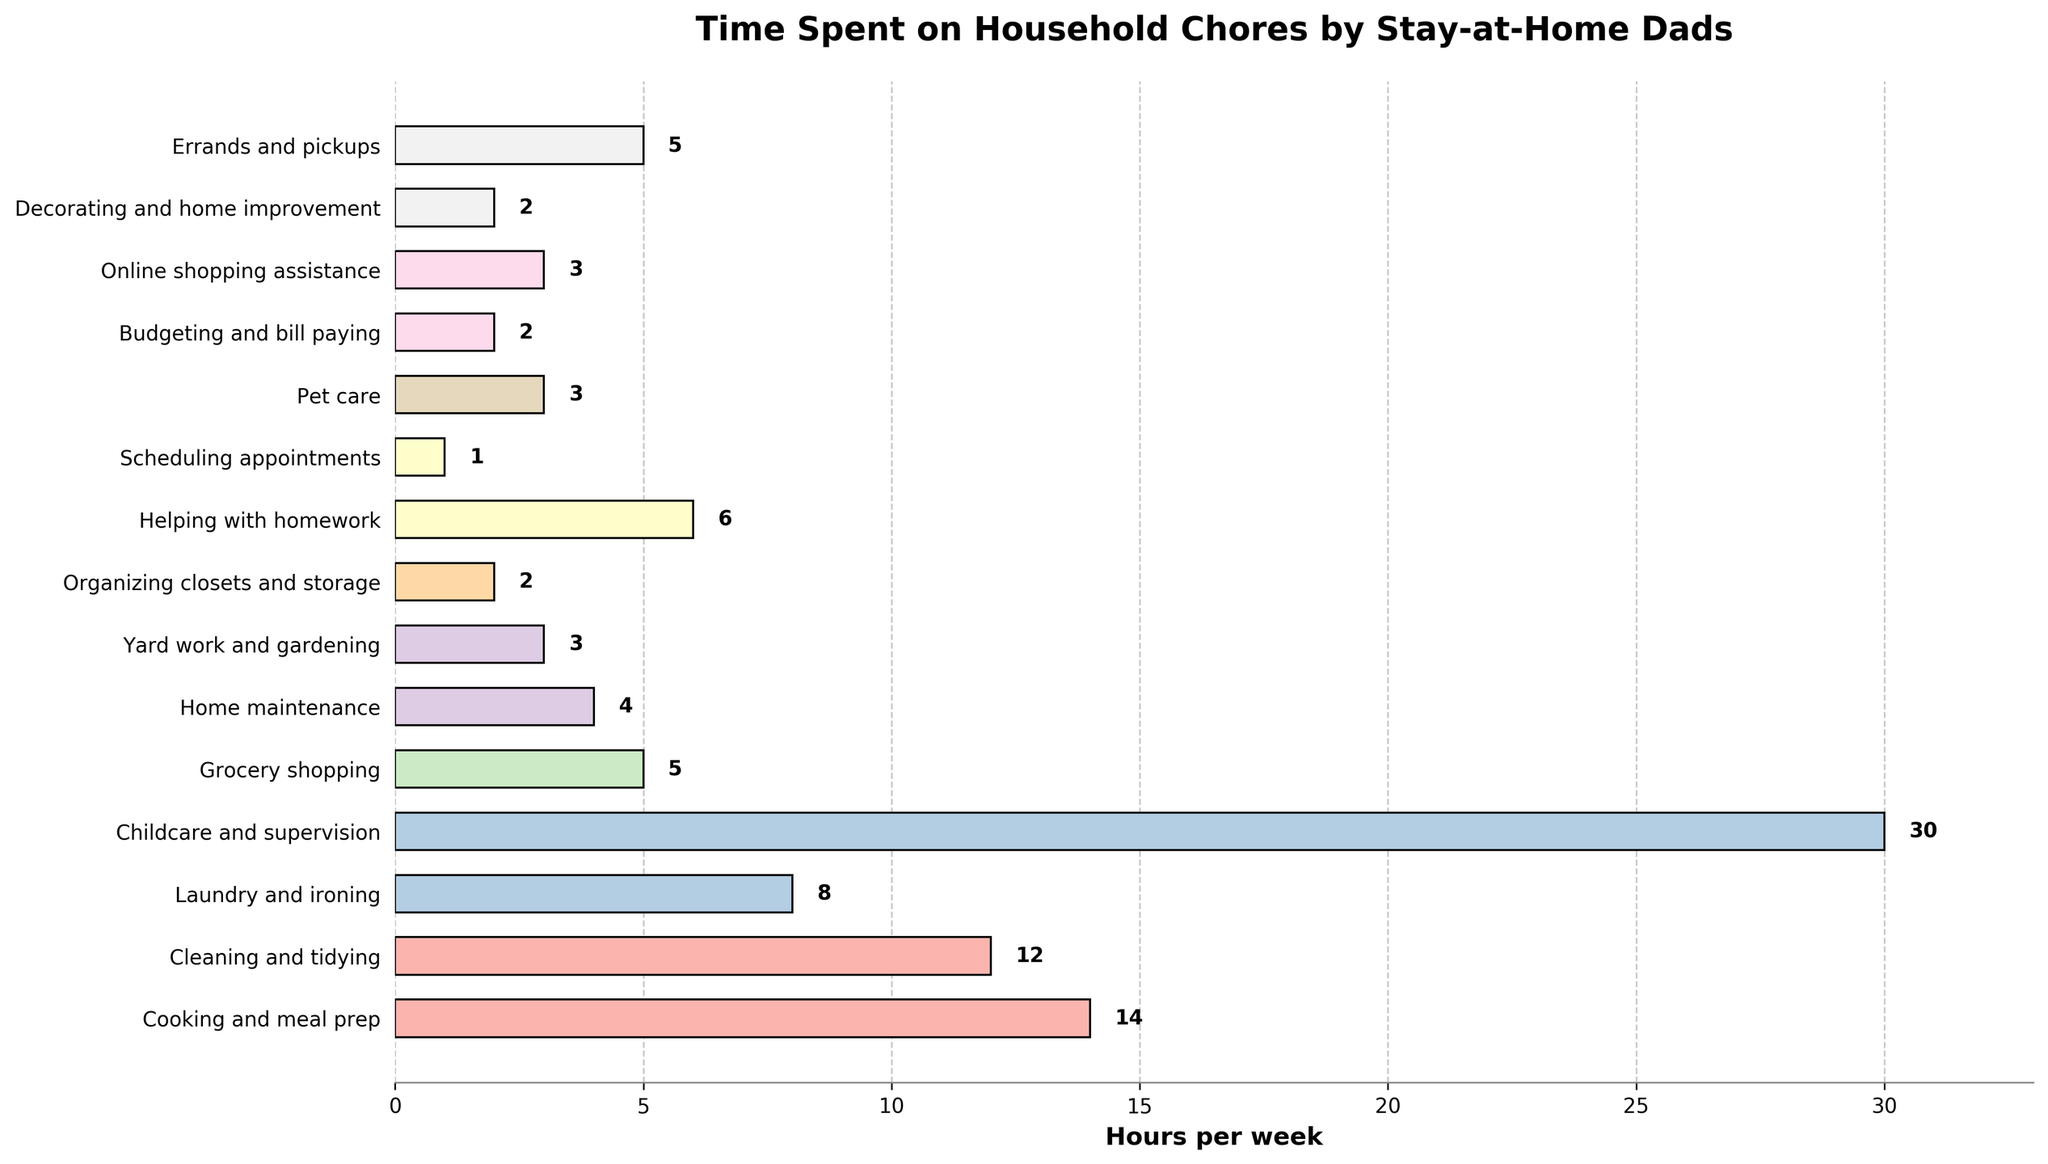What activity takes up the most time per week? The activity with the longest bar is the one that takes up the most time. The "Childcare and supervision" bar is the longest.
Answer: Childcare and supervision Which two activities have the closest number of hours spent? Compare the lengths of the bars. "Scheduling appointments" and "Budgeting and bill paying" have both 1 and 2 hours respectively, which are close to each other.
Answer: Scheduling appointments and Budgeting and bill paying How many total hours per week are spent on Cooking, Cleaning, and Grocery shopping combined? Add the hours for "Cooking and meal prep" (14), "Cleaning and tidying" (12), and "Grocery shopping" (5). 14 + 12 + 5 = 31.
Answer: 31 Which activity has a longer duration: Home maintenance or Yard work and gardening? Compare the lengths of the bars for "Home maintenance" (4) and "Yard work and gardening" (3).
Answer: Home maintenance Is there any activity where the time spent is less than 2 hours? Check if any bars have a value less than 2. All activities have 2 or more hours.
Answer: No What is the difference in hours spent between Childcare and supervision and Cleaning and tidying? Subtract the hours for "Cleaning and tidying" (12) from "Childcare and supervision" (30). 30 - 12 = 18.
Answer: 18 Which activities take the same amount of time per week? Visually inspect the bars and identify those of the same length. "Pet care", "Online shopping assistance" both have 3 hours. Also, "Organizing closets and storage", "Decorating and home improvement", "Budgeting and bill paying" each have 2 hours.
Answer: Pet care, Online shopping assistance; Organizing closets and storage, Decorating and home improvement, Budgeting and bill paying What percentage of the total household chore time is spent on Childcare and supervision? First, sum all the hours: 14 + 12 + 8 + 30 + 5 + 4 + 3 + 2 + 6 + 1 + 3 + 2 + 3 + 2 + 5 = 100 hours. Then, calculate the percentage of 30 (Childcare and supervision) out of 100. (30 / 100) * 100 = 30%.
Answer: 30% If the average time spent on each activity is calculated, would Helping with homework be above or below the average? Sum all the hours and divide by the number of activities. Total is 100 hours and there are 15 activities. 100 / 15 = approximately 6.67 hours. "Helping with homework" is 6 hours, which is below the average of 6.67 hours.
Answer: Below 